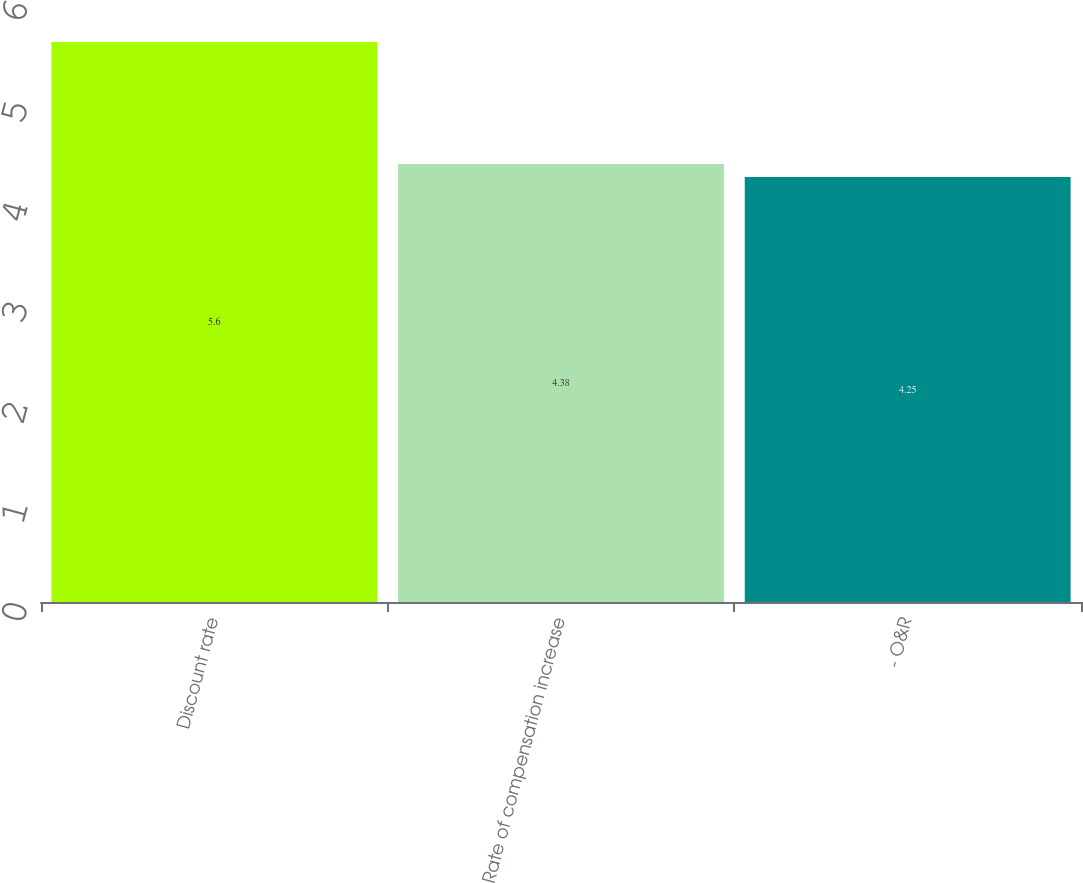<chart> <loc_0><loc_0><loc_500><loc_500><bar_chart><fcel>Discount rate<fcel>Rate of compensation increase<fcel>- O&R<nl><fcel>5.6<fcel>4.38<fcel>4.25<nl></chart> 